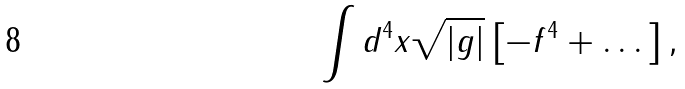<formula> <loc_0><loc_0><loc_500><loc_500>\int d ^ { 4 } x \sqrt { | g | } \left [ - f ^ { 4 } + \dots \right ] ,</formula> 